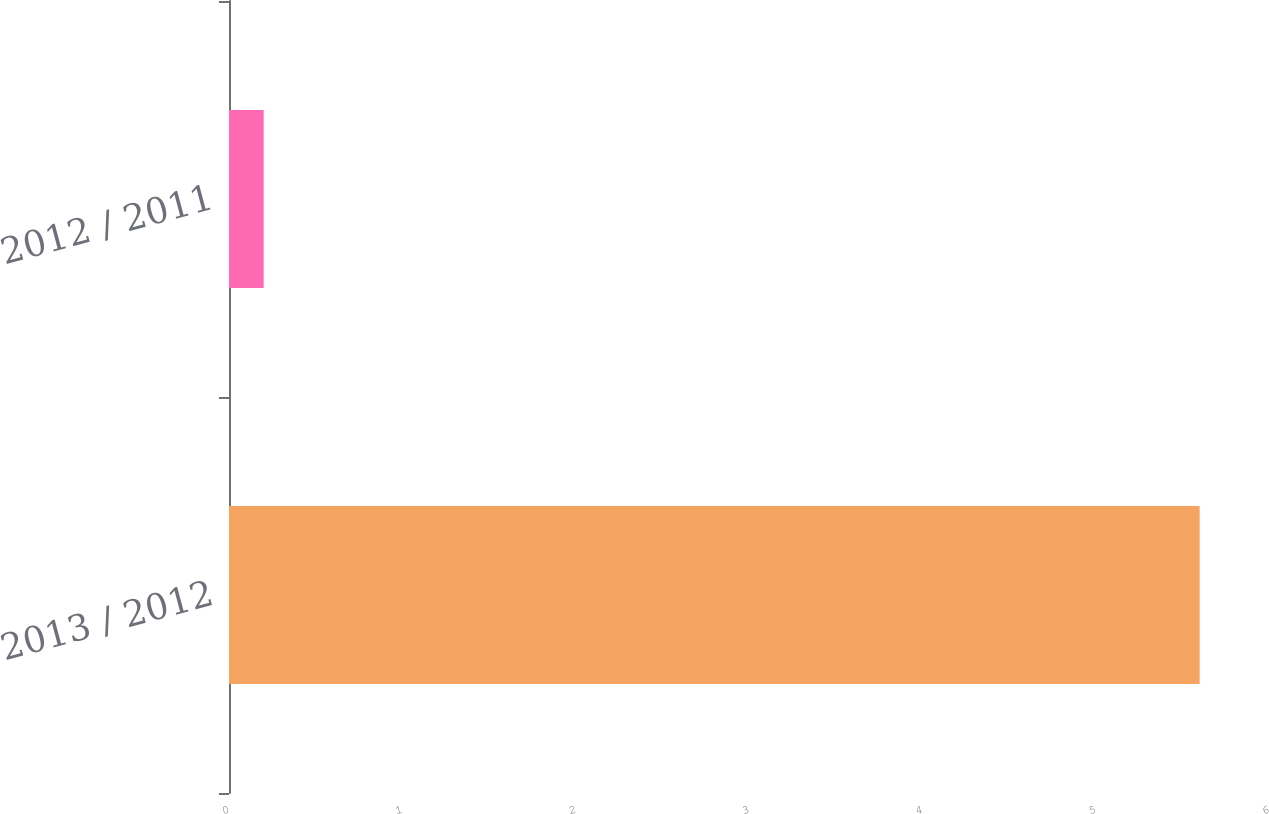<chart> <loc_0><loc_0><loc_500><loc_500><bar_chart><fcel>2013 / 2012<fcel>2012 / 2011<nl><fcel>5.6<fcel>0.2<nl></chart> 